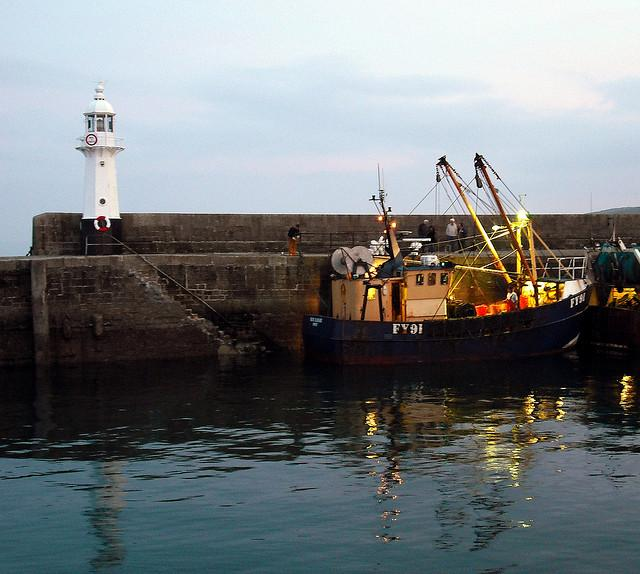When it is dark at night what will the boats use as navigation? Please explain your reasoning. lighthouse. This helps sailors see on stormy nights 